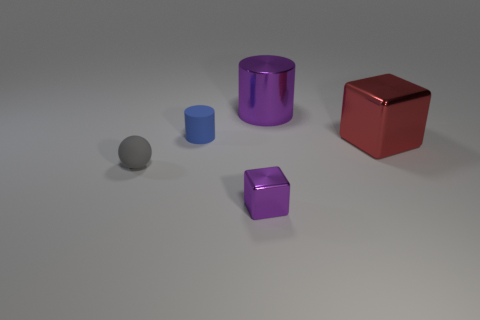There is another object that is the same material as the small blue object; what size is it?
Make the answer very short. Small. What is the material of the red object?
Make the answer very short. Metal. What number of purple shiny spheres are the same size as the rubber cylinder?
Offer a very short reply. 0. What shape is the thing that is the same color as the tiny block?
Offer a terse response. Cylinder. Is there a small matte object of the same shape as the tiny metallic thing?
Your response must be concise. No. What color is the cylinder that is the same size as the red metallic object?
Offer a terse response. Purple. There is a large shiny object that is in front of the cylinder that is on the left side of the big cylinder; what is its color?
Your answer should be compact. Red. There is a matte object that is in front of the red shiny thing; is its color the same as the small rubber cylinder?
Your response must be concise. No. What is the shape of the purple metallic object that is in front of the cylinder that is behind the matte object behind the small gray object?
Give a very brief answer. Cube. There is a rubber object to the right of the matte ball; how many small purple blocks are to the left of it?
Your answer should be compact. 0. 